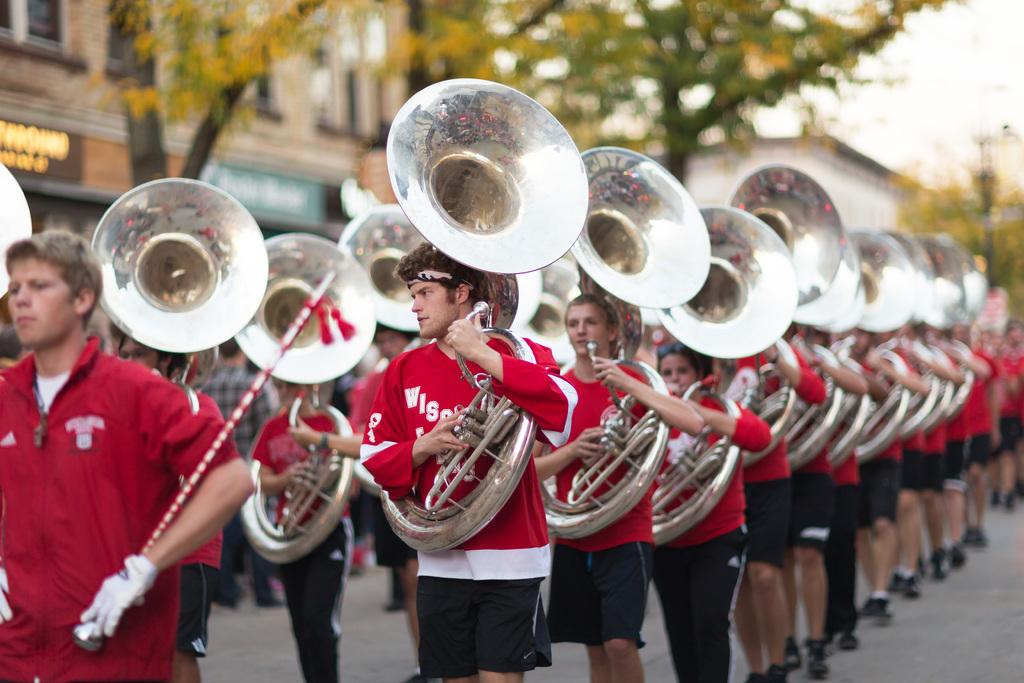What are the people in the image doing? The people in the image are holding trumpets. Is there any other object being held by one of the people? Yes, one person is holding a stick. What can be seen in the background of the image? There are trees, buildings, and the sky visible in the background of the image. What type of button can be seen on the trees in the image? There are no buttons present on the trees in the image; they are simply trees in the background. 